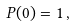Convert formula to latex. <formula><loc_0><loc_0><loc_500><loc_500>P ( 0 ) = 1 \, ,</formula> 